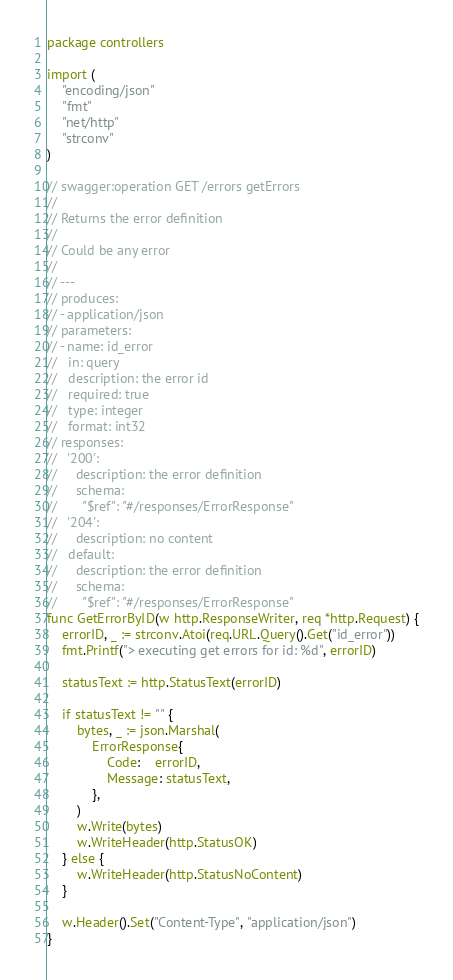<code> <loc_0><loc_0><loc_500><loc_500><_Go_>package controllers

import (
	"encoding/json"
	"fmt"
	"net/http"
	"strconv"
)

// swagger:operation GET /errors getErrors
//
// Returns the error definition
//
// Could be any error
//
// ---
// produces:
// - application/json
// parameters:
// - name: id_error
//   in: query
//   description: the error id
//   required: true
//   type: integer
//   format: int32
// responses:
//   '200':
//     description: the error definition
//     schema:
//       "$ref": "#/responses/ErrorResponse"
//   '204':
//     description: no content
//   default:
//     description: the error definition
//     schema:
//       "$ref": "#/responses/ErrorResponse"
func GetErrorByID(w http.ResponseWriter, req *http.Request) {
	errorID, _ := strconv.Atoi(req.URL.Query().Get("id_error"))
	fmt.Printf("> executing get errors for id: %d", errorID)

	statusText := http.StatusText(errorID)

	if statusText != "" {
		bytes, _ := json.Marshal(
			ErrorResponse{
				Code:    errorID,
				Message: statusText,
			},
		)
		w.Write(bytes)
		w.WriteHeader(http.StatusOK)
	} else {
		w.WriteHeader(http.StatusNoContent)
	}

	w.Header().Set("Content-Type", "application/json")
}
</code> 